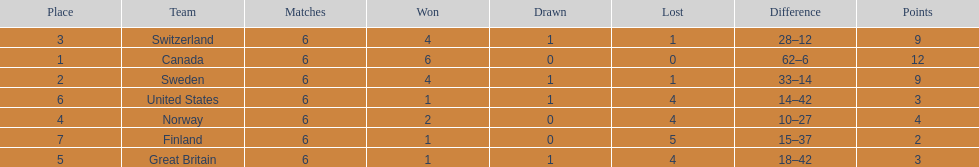What team placed after canada? Sweden. 